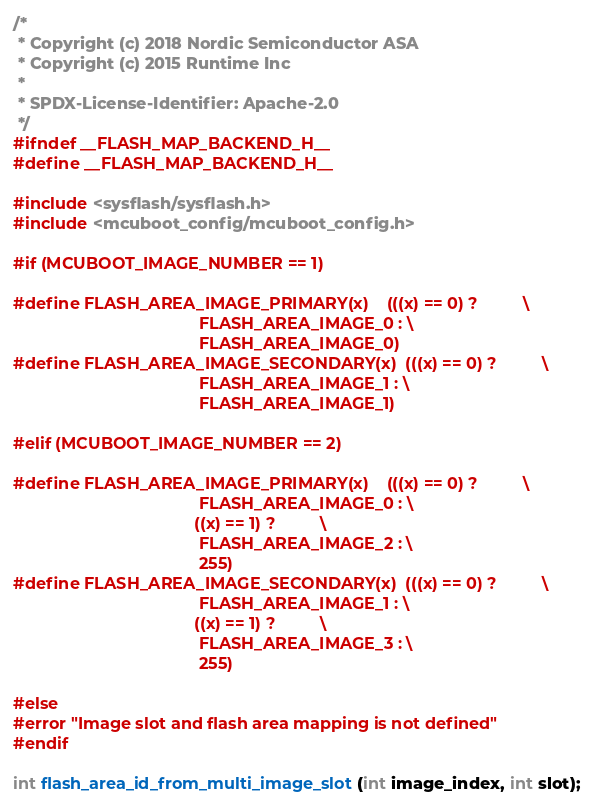<code> <loc_0><loc_0><loc_500><loc_500><_C_>/*
 * Copyright (c) 2018 Nordic Semiconductor ASA
 * Copyright (c) 2015 Runtime Inc
 *
 * SPDX-License-Identifier: Apache-2.0
 */
#ifndef __FLASH_MAP_BACKEND_H__
#define __FLASH_MAP_BACKEND_H__

#include <sysflash/sysflash.h>
#include <mcuboot_config/mcuboot_config.h>

#if (MCUBOOT_IMAGE_NUMBER == 1)

#define FLASH_AREA_IMAGE_PRIMARY(x)    (((x) == 0) ?          \
                                         FLASH_AREA_IMAGE_0 : \
                                         FLASH_AREA_IMAGE_0)
#define FLASH_AREA_IMAGE_SECONDARY(x)  (((x) == 0) ?          \
                                         FLASH_AREA_IMAGE_1 : \
                                         FLASH_AREA_IMAGE_1)

#elif (MCUBOOT_IMAGE_NUMBER == 2)

#define FLASH_AREA_IMAGE_PRIMARY(x)    (((x) == 0) ?          \
                                         FLASH_AREA_IMAGE_0 : \
                                        ((x) == 1) ?          \
                                         FLASH_AREA_IMAGE_2 : \
                                         255)
#define FLASH_AREA_IMAGE_SECONDARY(x)  (((x) == 0) ?          \
                                         FLASH_AREA_IMAGE_1 : \
                                        ((x) == 1) ?          \
                                         FLASH_AREA_IMAGE_3 : \
                                         255)

#else
#error "Image slot and flash area mapping is not defined"
#endif

int flash_area_id_from_multi_image_slot(int image_index, int slot);</code> 